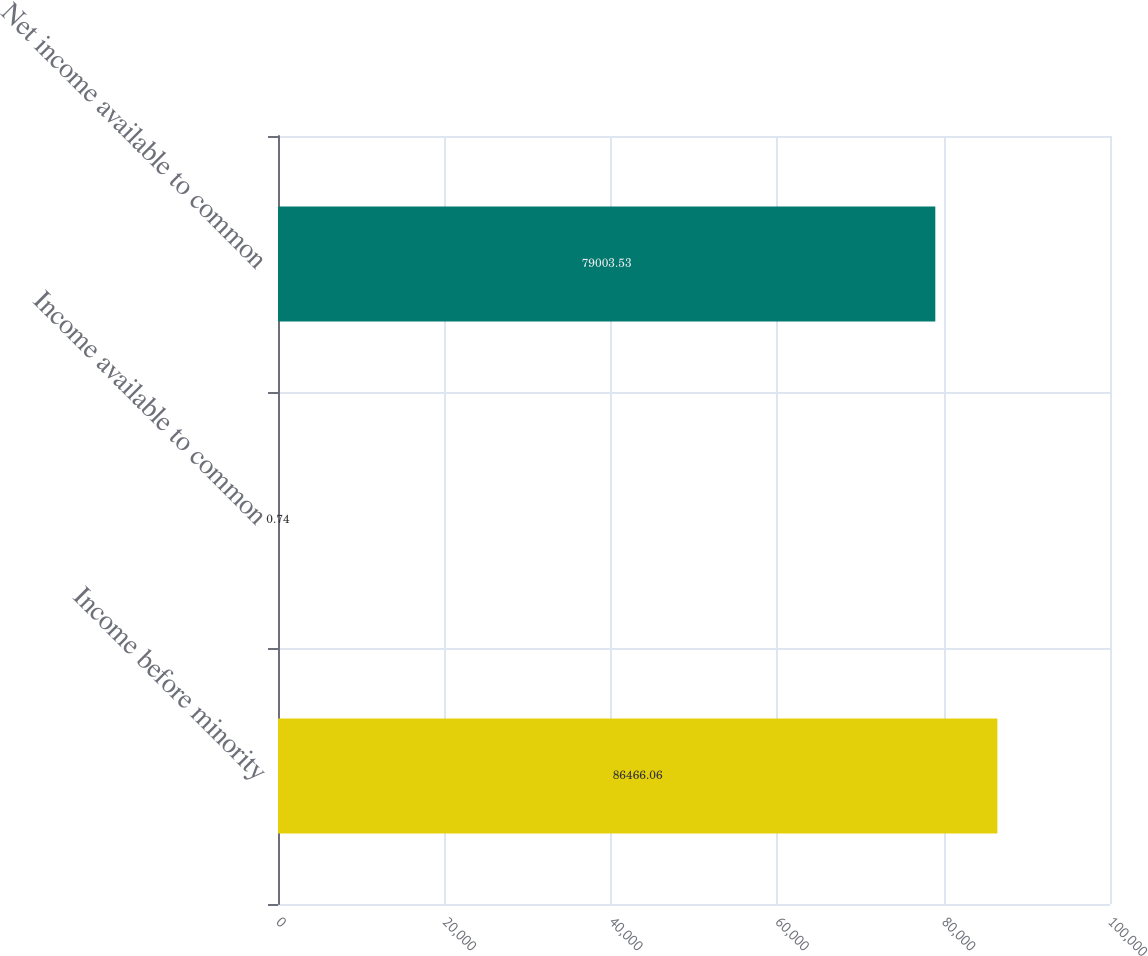<chart> <loc_0><loc_0><loc_500><loc_500><bar_chart><fcel>Income before minority<fcel>Income available to common<fcel>Net income available to common<nl><fcel>86466.1<fcel>0.74<fcel>79003.5<nl></chart> 